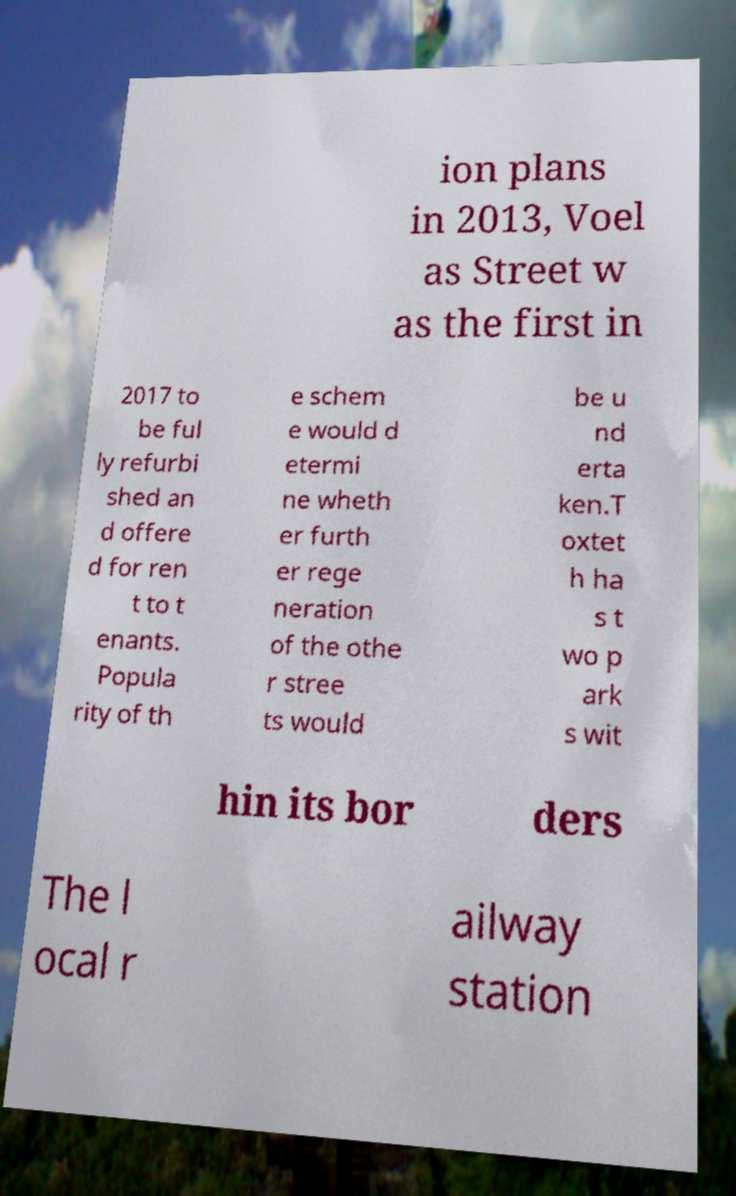For documentation purposes, I need the text within this image transcribed. Could you provide that? ion plans in 2013, Voel as Street w as the first in 2017 to be ful ly refurbi shed an d offere d for ren t to t enants. Popula rity of th e schem e would d etermi ne wheth er furth er rege neration of the othe r stree ts would be u nd erta ken.T oxtet h ha s t wo p ark s wit hin its bor ders The l ocal r ailway station 